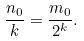<formula> <loc_0><loc_0><loc_500><loc_500>\frac { n _ { 0 } } { k } = \frac { m _ { 0 } } { 2 ^ { k } } .</formula> 